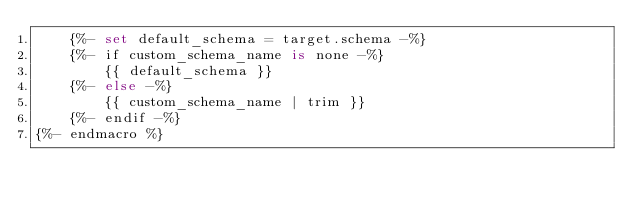Convert code to text. <code><loc_0><loc_0><loc_500><loc_500><_SQL_>    {%- set default_schema = target.schema -%}
    {%- if custom_schema_name is none -%}
        {{ default_schema }}
    {%- else -%}
        {{ custom_schema_name | trim }}
    {%- endif -%}
{%- endmacro %}</code> 